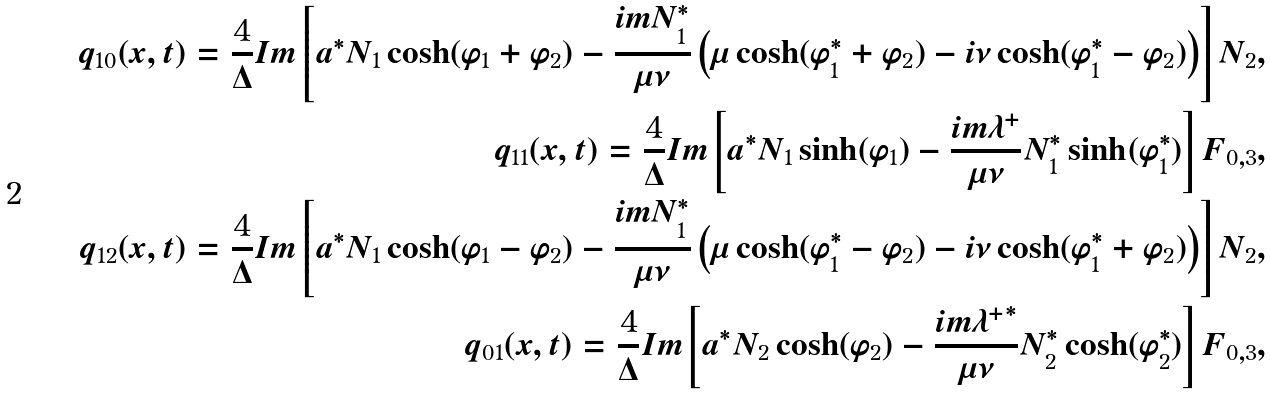<formula> <loc_0><loc_0><loc_500><loc_500>q _ { 1 0 } ( x , t ) = \frac { 4 } { \Delta } I m \left [ a ^ { \ast } N _ { 1 } \cosh ( \varphi _ { 1 } + \varphi _ { 2 } ) - \frac { i m N _ { 1 } ^ { \ast } } { \mu \nu } \left ( \mu \cosh ( \varphi ^ { \ast } _ { 1 } + \varphi _ { 2 } ) - i \nu \cosh ( \varphi ^ { \ast } _ { 1 } - \varphi _ { 2 } ) \right ) \right ] N _ { 2 } , \\ q _ { 1 1 } ( x , t ) = \frac { 4 } { \Delta } I m \left [ a ^ { \ast } N _ { 1 } \sinh ( \varphi _ { 1 } ) - \frac { i m \lambda ^ { + } } { \mu \nu } N ^ { \ast } _ { 1 } \sinh ( \varphi ^ { \ast } _ { 1 } ) \right ] F _ { 0 , 3 } , \\ q _ { 1 2 } ( x , t ) = \frac { 4 } { \Delta } I m \left [ a ^ { \ast } N _ { 1 } \cosh ( \varphi _ { 1 } - \varphi _ { 2 } ) - \frac { i m N ^ { \ast } _ { 1 } } { \mu \nu } \left ( \mu \cosh ( \varphi ^ { \ast } _ { 1 } - \varphi _ { 2 } ) - i \nu \cosh ( \varphi ^ { \ast } _ { 1 } + \varphi _ { 2 } ) \right ) \right ] N _ { 2 } , \\ q _ { 0 1 } ( x , t ) = \frac { 4 } { \Delta } I m \left [ a ^ { \ast } N _ { 2 } \cosh ( \varphi _ { 2 } ) - \frac { i m { \lambda ^ { + } } ^ { \ast } } { \mu \nu } N ^ { \ast } _ { 2 } \cosh ( \varphi ^ { \ast } _ { 2 } ) \right ] F _ { 0 , 3 } ,</formula> 